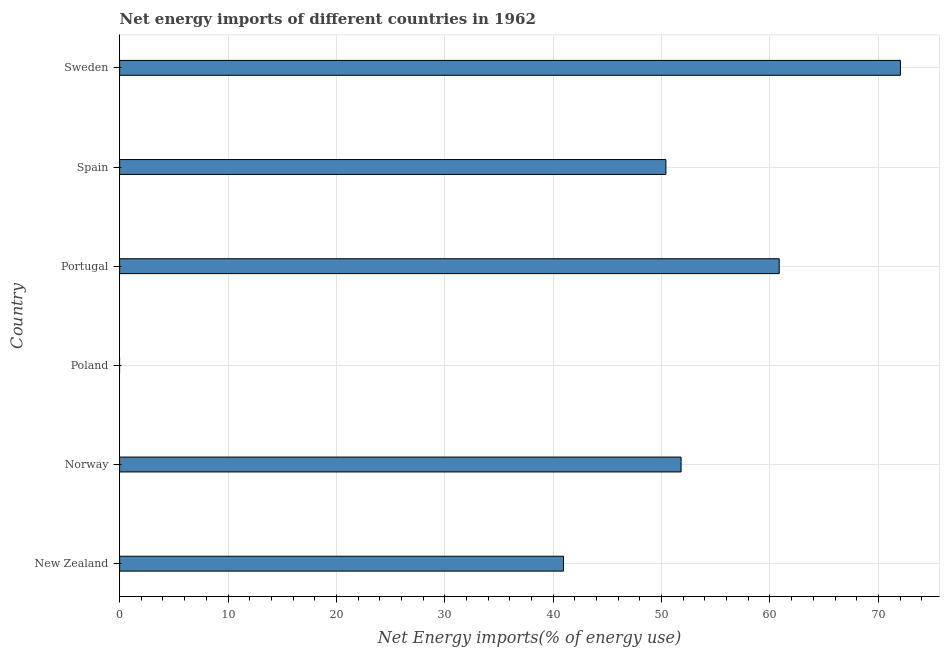Does the graph contain any zero values?
Provide a short and direct response. Yes. What is the title of the graph?
Provide a succinct answer. Net energy imports of different countries in 1962. What is the label or title of the X-axis?
Provide a short and direct response. Net Energy imports(% of energy use). Across all countries, what is the maximum energy imports?
Provide a succinct answer. 72.04. In which country was the energy imports maximum?
Provide a succinct answer. Sweden. What is the sum of the energy imports?
Provide a short and direct response. 276.04. What is the difference between the energy imports in New Zealand and Portugal?
Offer a terse response. -19.9. What is the average energy imports per country?
Offer a very short reply. 46.01. What is the median energy imports?
Give a very brief answer. 51.1. In how many countries, is the energy imports greater than 10 %?
Your answer should be very brief. 5. What is the ratio of the energy imports in New Zealand to that in Spain?
Your answer should be compact. 0.81. Is the energy imports in Norway less than that in Sweden?
Your answer should be compact. Yes. Is the difference between the energy imports in Portugal and Spain greater than the difference between any two countries?
Your response must be concise. No. What is the difference between the highest and the second highest energy imports?
Provide a succinct answer. 11.18. What is the difference between the highest and the lowest energy imports?
Your answer should be compact. 72.04. How many bars are there?
Ensure brevity in your answer.  5. What is the difference between two consecutive major ticks on the X-axis?
Keep it short and to the point. 10. What is the Net Energy imports(% of energy use) in New Zealand?
Make the answer very short. 40.95. What is the Net Energy imports(% of energy use) of Norway?
Offer a terse response. 51.8. What is the Net Energy imports(% of energy use) in Poland?
Give a very brief answer. 0. What is the Net Energy imports(% of energy use) of Portugal?
Offer a very short reply. 60.85. What is the Net Energy imports(% of energy use) of Spain?
Ensure brevity in your answer.  50.4. What is the Net Energy imports(% of energy use) in Sweden?
Ensure brevity in your answer.  72.04. What is the difference between the Net Energy imports(% of energy use) in New Zealand and Norway?
Make the answer very short. -10.85. What is the difference between the Net Energy imports(% of energy use) in New Zealand and Portugal?
Your response must be concise. -19.9. What is the difference between the Net Energy imports(% of energy use) in New Zealand and Spain?
Provide a succinct answer. -9.45. What is the difference between the Net Energy imports(% of energy use) in New Zealand and Sweden?
Your answer should be compact. -31.09. What is the difference between the Net Energy imports(% of energy use) in Norway and Portugal?
Provide a succinct answer. -9.05. What is the difference between the Net Energy imports(% of energy use) in Norway and Spain?
Your answer should be very brief. 1.4. What is the difference between the Net Energy imports(% of energy use) in Norway and Sweden?
Your answer should be compact. -20.24. What is the difference between the Net Energy imports(% of energy use) in Portugal and Spain?
Offer a terse response. 10.46. What is the difference between the Net Energy imports(% of energy use) in Portugal and Sweden?
Give a very brief answer. -11.18. What is the difference between the Net Energy imports(% of energy use) in Spain and Sweden?
Ensure brevity in your answer.  -21.64. What is the ratio of the Net Energy imports(% of energy use) in New Zealand to that in Norway?
Keep it short and to the point. 0.79. What is the ratio of the Net Energy imports(% of energy use) in New Zealand to that in Portugal?
Your answer should be compact. 0.67. What is the ratio of the Net Energy imports(% of energy use) in New Zealand to that in Spain?
Make the answer very short. 0.81. What is the ratio of the Net Energy imports(% of energy use) in New Zealand to that in Sweden?
Your answer should be very brief. 0.57. What is the ratio of the Net Energy imports(% of energy use) in Norway to that in Portugal?
Provide a succinct answer. 0.85. What is the ratio of the Net Energy imports(% of energy use) in Norway to that in Spain?
Your answer should be compact. 1.03. What is the ratio of the Net Energy imports(% of energy use) in Norway to that in Sweden?
Provide a succinct answer. 0.72. What is the ratio of the Net Energy imports(% of energy use) in Portugal to that in Spain?
Provide a short and direct response. 1.21. What is the ratio of the Net Energy imports(% of energy use) in Portugal to that in Sweden?
Offer a terse response. 0.84. What is the ratio of the Net Energy imports(% of energy use) in Spain to that in Sweden?
Ensure brevity in your answer.  0.7. 